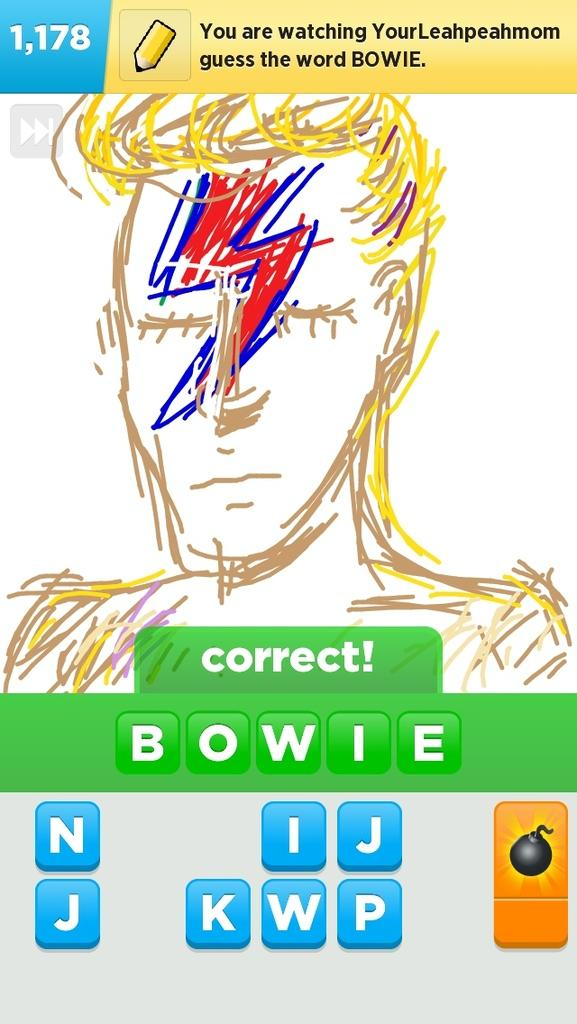What is the main subject of the image? The main subject of the image is a sketch. Are there any words or letters in the image? Yes, there is text in the image. What symbol can be seen on the right side of the image? There is a symbol of a bomb on the right side of the image. What type of songs can be heard playing in the background of the image? There is no audio or music present in the image, so it is not possible to determine what songs might be heard. 